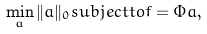<formula> <loc_0><loc_0><loc_500><loc_500>\min _ { a } \| a \| _ { 0 } s u b j e c t t o f = \Phi a ,</formula> 